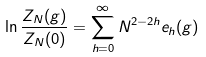<formula> <loc_0><loc_0><loc_500><loc_500>\ln \frac { Z _ { N } ( { g } ) } { Z _ { N } ( { 0 } ) } = \sum _ { h = 0 } ^ { \infty } N ^ { 2 - 2 h } e _ { h } ( { g } )</formula> 